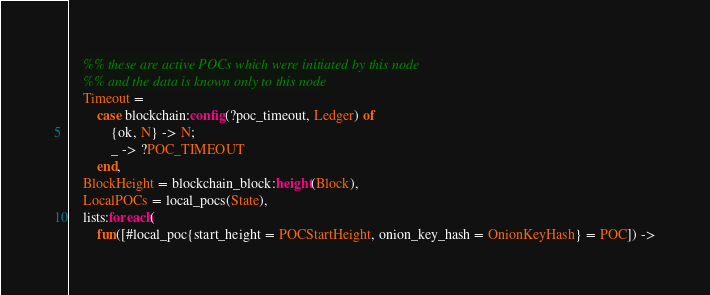<code> <loc_0><loc_0><loc_500><loc_500><_Erlang_>    %% these are active POCs which were initiated by this node
    %% and the data is known only to this node
    Timeout =
        case blockchain:config(?poc_timeout, Ledger) of
            {ok, N} -> N;
            _ -> ?POC_TIMEOUT
        end,
    BlockHeight = blockchain_block:height(Block),
    LocalPOCs = local_pocs(State),
    lists:foreach(
        fun([#local_poc{start_height = POCStartHeight, onion_key_hash = OnionKeyHash} = POC]) -></code> 